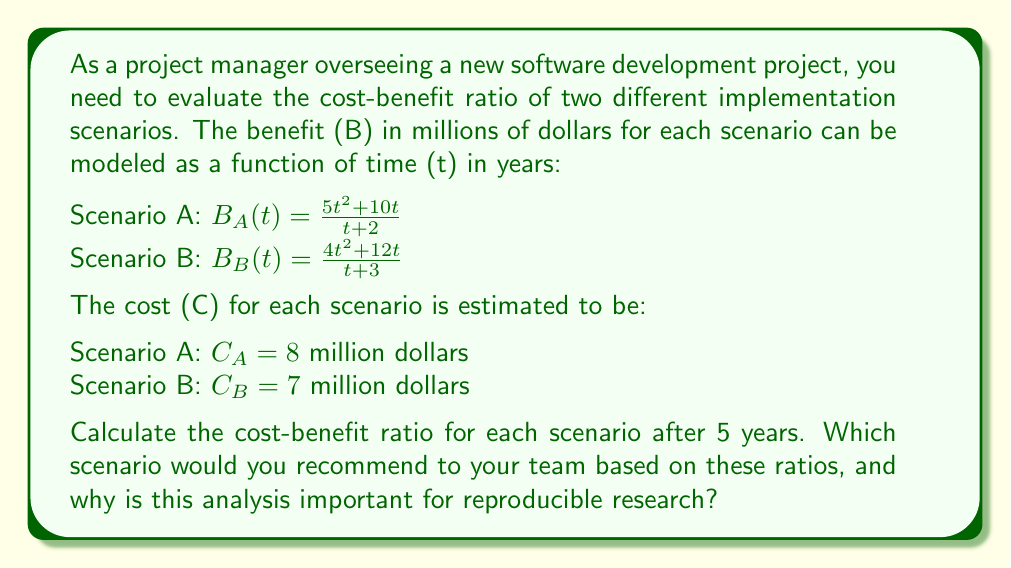Help me with this question. To solve this problem, we need to follow these steps:

1. Calculate the benefit for each scenario at t = 5 years
2. Compute the cost-benefit ratio for each scenario
3. Compare the ratios and make a recommendation

Step 1: Calculate the benefit for each scenario at t = 5 years

For Scenario A:
$$B_A(5) = \frac{5(5)^2 + 10(5)}{5 + 2} = \frac{125 + 50}{7} = \frac{175}{7} = 25$$

For Scenario B:
$$B_B(5) = \frac{4(5)^2 + 12(5)}{5 + 3} = \frac{100 + 60}{8} = \frac{160}{8} = 20$$

Step 2: Compute the cost-benefit ratio for each scenario

The cost-benefit ratio is calculated as Cost / Benefit

For Scenario A:
$$\text{Ratio}_A = \frac{C_A}{B_A(5)} = \frac{8}{25} = 0.32$$

For Scenario B:
$$\text{Ratio}_B = \frac{C_B}{B_B(5)} = \frac{7}{20} = 0.35$$

Step 3: Compare the ratios and make a recommendation

A lower cost-benefit ratio is better, as it indicates more benefit per unit of cost. In this case, Scenario A has a lower ratio (0.32) compared to Scenario B (0.35), so Scenario A would be the recommended choice.

This analysis is important for reproducible research because:

1. It provides a clear, quantitative basis for decision-making.
2. The calculations and methodology can be easily replicated by other team members or researchers.
3. It allows for sensitivity analysis by adjusting parameters and observing how they affect the outcome.
4. It creates a documented process that can be referenced and improved upon in future projects.
Answer: Scenario A cost-benefit ratio: 0.32
Scenario B cost-benefit ratio: 0.35

Recommend Scenario A, as it has a lower cost-benefit ratio, indicating better value for the investment. 